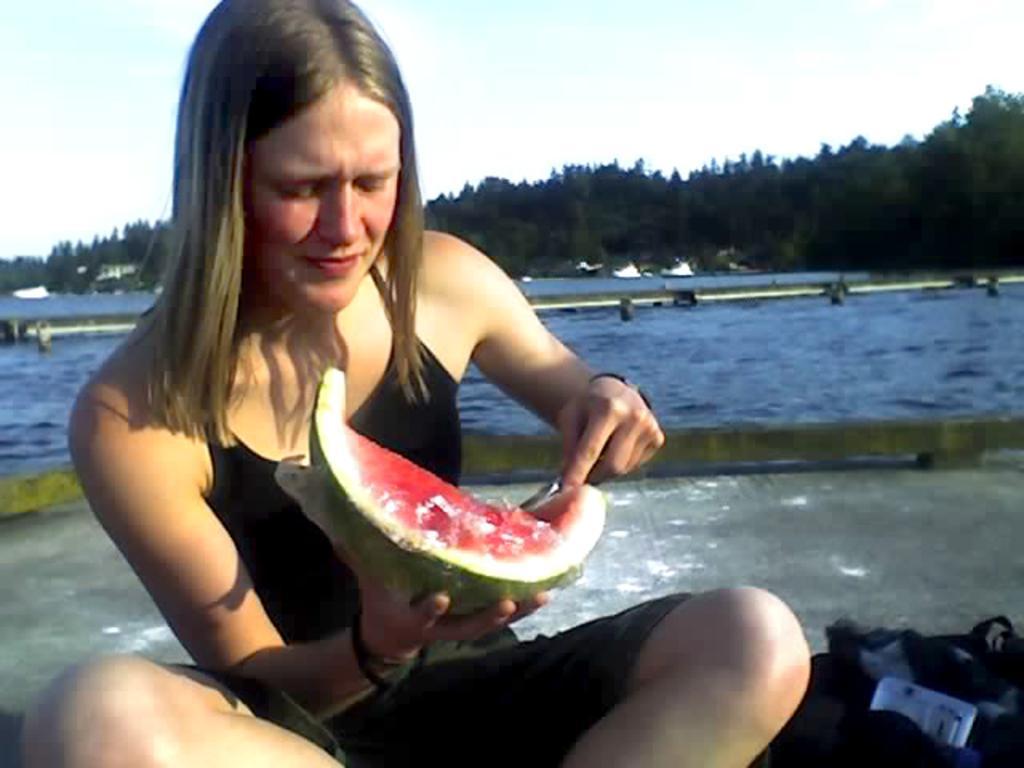Please provide a concise description of this image. In this image there is a woman sitting on the ground. She is holding a slice of a watermelon. Beside her there is a bag on the ground. Behind her there is the water. In the background there are trees. At the top there is the sky. 